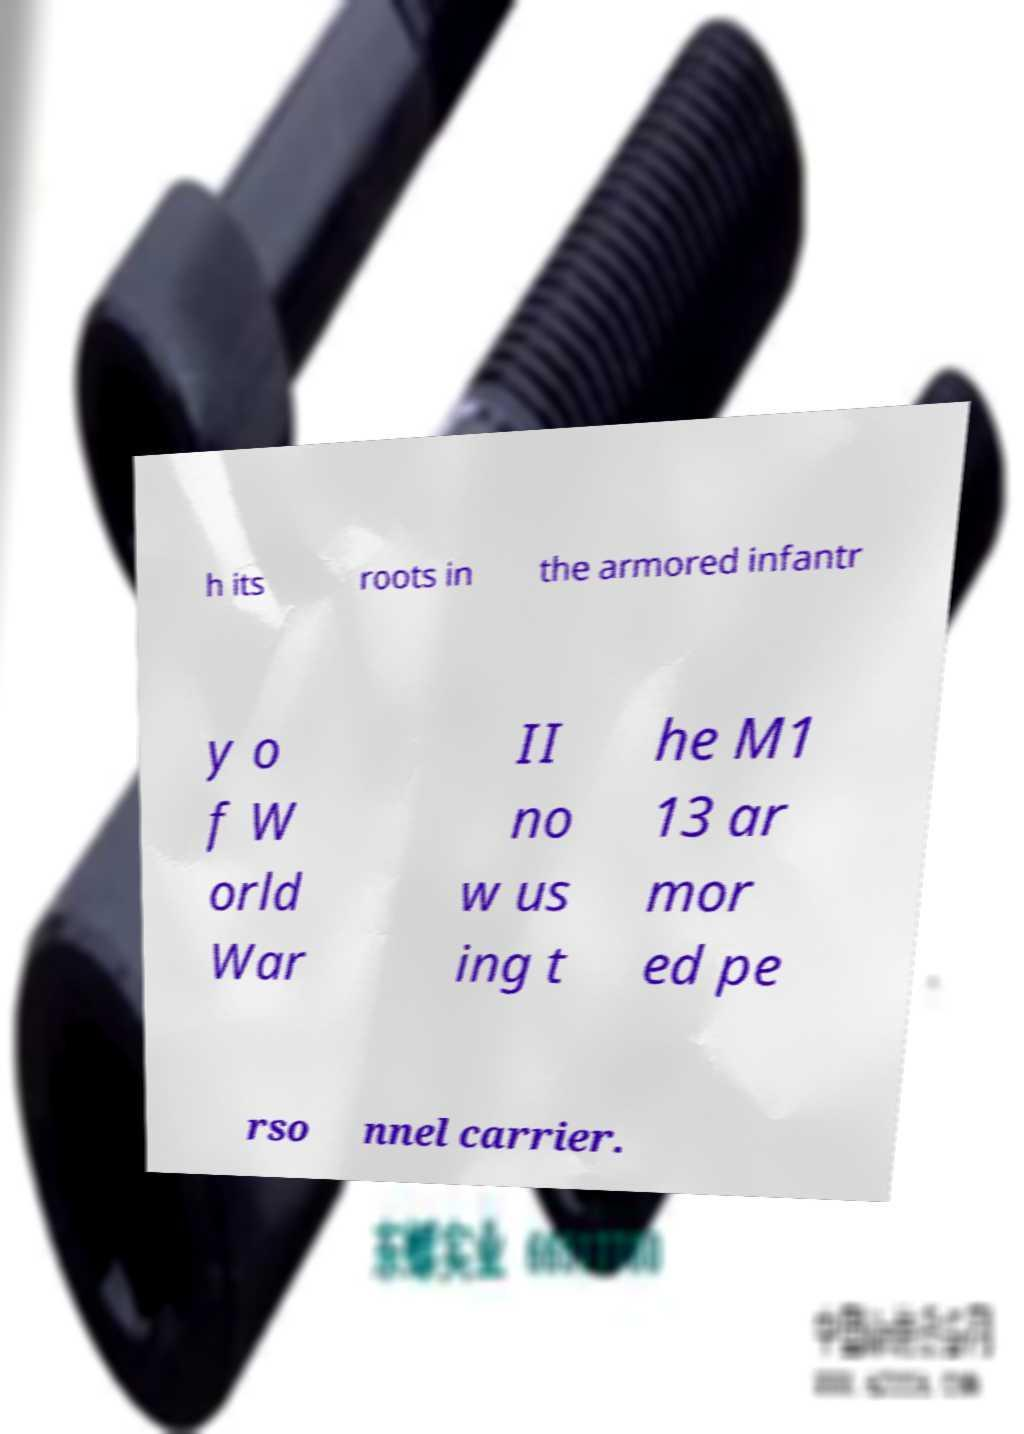Could you assist in decoding the text presented in this image and type it out clearly? h its roots in the armored infantr y o f W orld War II no w us ing t he M1 13 ar mor ed pe rso nnel carrier. 